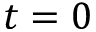<formula> <loc_0><loc_0><loc_500><loc_500>t = 0</formula> 